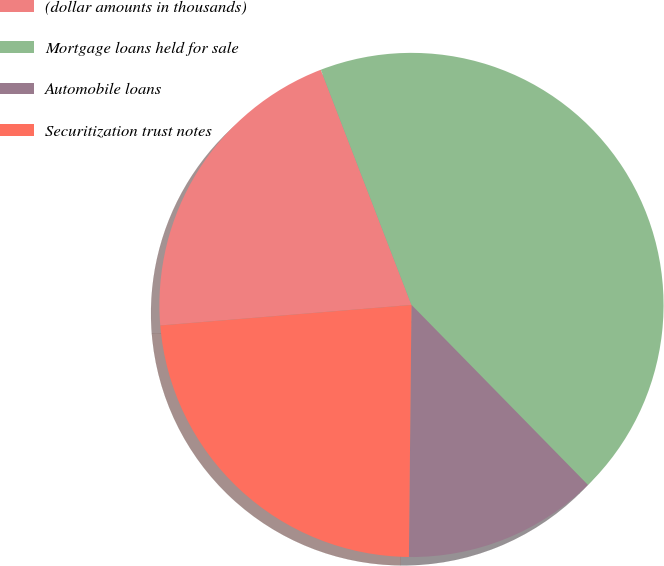Convert chart to OTSL. <chart><loc_0><loc_0><loc_500><loc_500><pie_chart><fcel>(dollar amounts in thousands)<fcel>Mortgage loans held for sale<fcel>Automobile loans<fcel>Securitization trust notes<nl><fcel>20.44%<fcel>43.52%<fcel>12.5%<fcel>23.54%<nl></chart> 